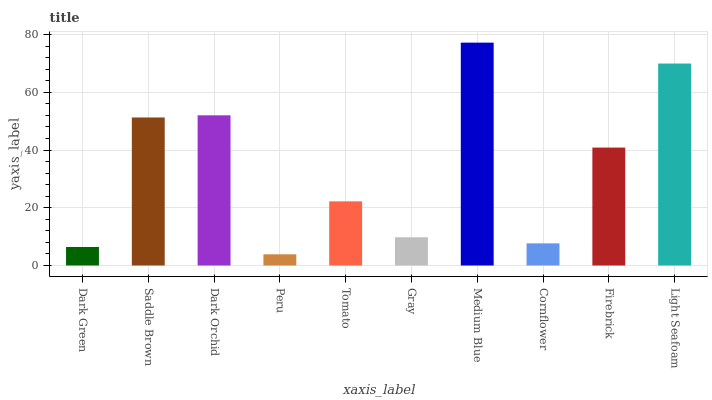Is Saddle Brown the minimum?
Answer yes or no. No. Is Saddle Brown the maximum?
Answer yes or no. No. Is Saddle Brown greater than Dark Green?
Answer yes or no. Yes. Is Dark Green less than Saddle Brown?
Answer yes or no. Yes. Is Dark Green greater than Saddle Brown?
Answer yes or no. No. Is Saddle Brown less than Dark Green?
Answer yes or no. No. Is Firebrick the high median?
Answer yes or no. Yes. Is Tomato the low median?
Answer yes or no. Yes. Is Tomato the high median?
Answer yes or no. No. Is Dark Orchid the low median?
Answer yes or no. No. 